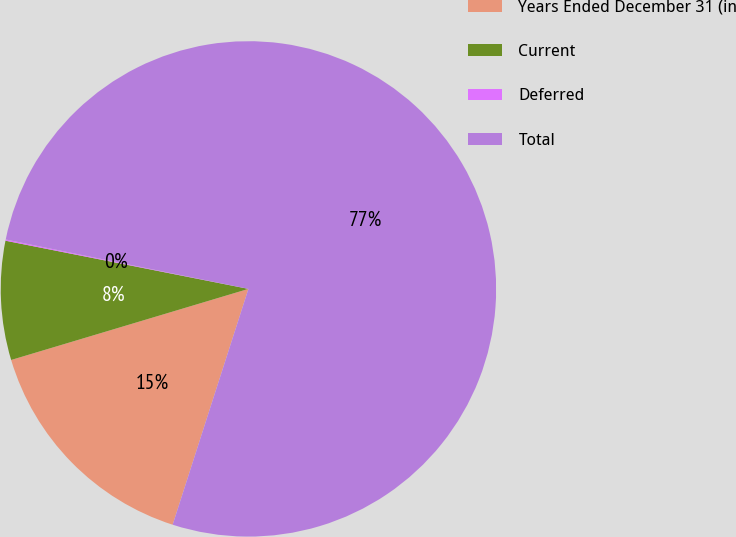<chart> <loc_0><loc_0><loc_500><loc_500><pie_chart><fcel>Years Ended December 31 (in<fcel>Current<fcel>Deferred<fcel>Total<nl><fcel>15.42%<fcel>7.75%<fcel>0.08%<fcel>76.76%<nl></chart> 